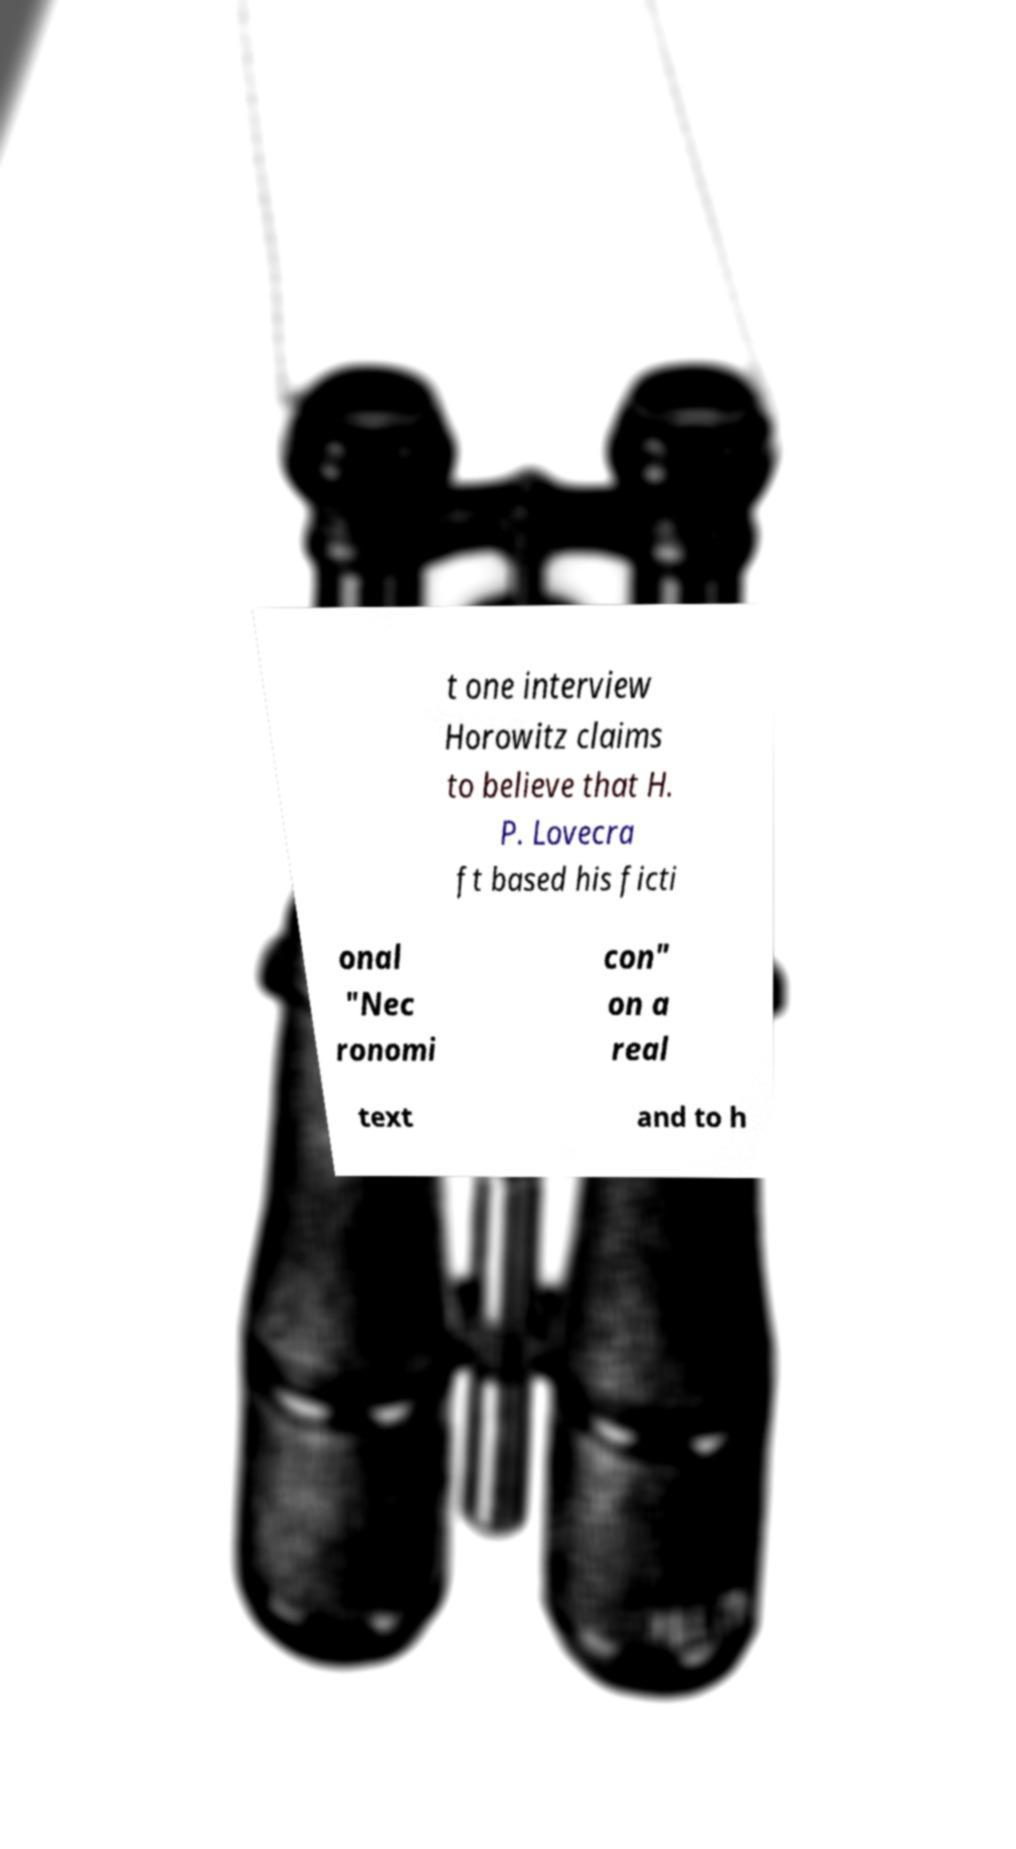For documentation purposes, I need the text within this image transcribed. Could you provide that? t one interview Horowitz claims to believe that H. P. Lovecra ft based his ficti onal "Nec ronomi con" on a real text and to h 